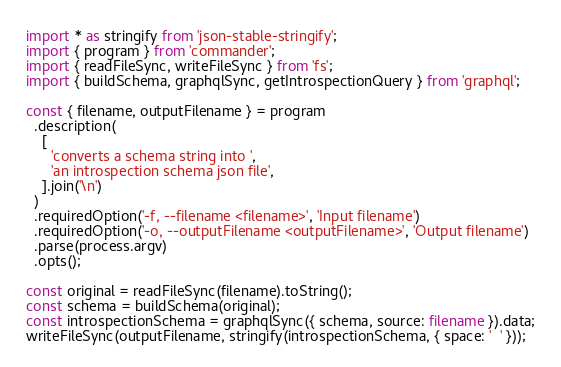<code> <loc_0><loc_0><loc_500><loc_500><_TypeScript_>import * as stringify from 'json-stable-stringify';
import { program } from 'commander';
import { readFileSync, writeFileSync } from 'fs';
import { buildSchema, graphqlSync, getIntrospectionQuery } from 'graphql';

const { filename, outputFilename } = program
  .description(
    [
      'converts a schema string into ',
      'an introspection schema json file',
    ].join('\n')
  )
  .requiredOption('-f, --filename <filename>', 'Input filename')
  .requiredOption('-o, --outputFilename <outputFilename>', 'Output filename')
  .parse(process.argv)
  .opts();

const original = readFileSync(filename).toString();
const schema = buildSchema(original);
const introspectionSchema = graphqlSync({ schema, source: filename }).data;
writeFileSync(outputFilename, stringify(introspectionSchema, { space: '  ' }));
</code> 